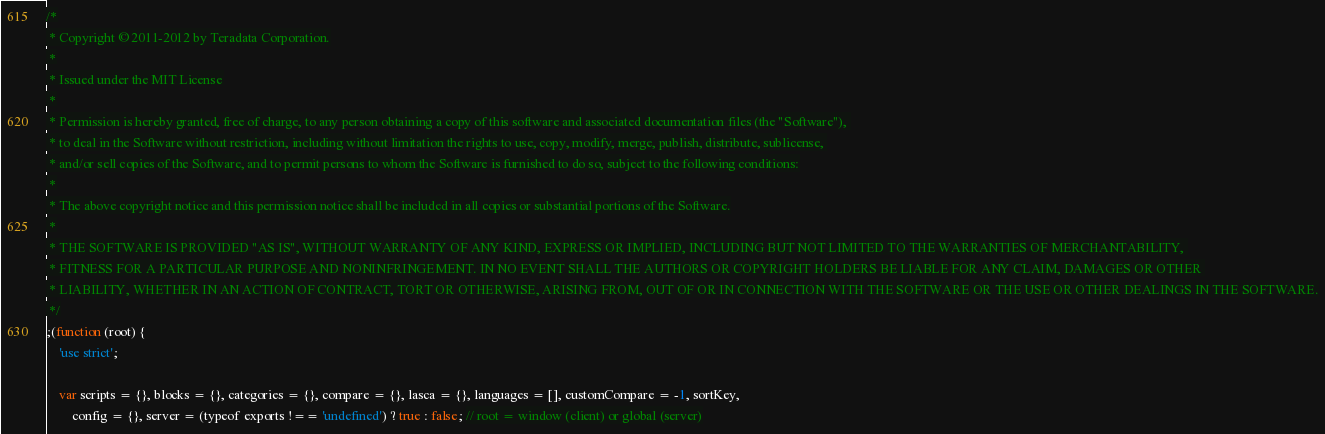<code> <loc_0><loc_0><loc_500><loc_500><_JavaScript_>/*
 * Copyright © 2011-2012 by Teradata Corporation.
 *
 * Issued under the MIT License
 *
 * Permission is hereby granted, free of charge, to any person obtaining a copy of this software and associated documentation files (the "Software"), 
 * to deal in the Software without restriction, including without limitation the rights to use, copy, modify, merge, publish, distribute, sublicense, 
 * and/or sell copies of the Software, and to permit persons to whom the Software is furnished to do so, subject to the following conditions:
 *
 * The above copyright notice and this permission notice shall be included in all copies or substantial portions of the Software.
 *
 * THE SOFTWARE IS PROVIDED "AS IS", WITHOUT WARRANTY OF ANY KIND, EXPRESS OR IMPLIED, INCLUDING BUT NOT LIMITED TO THE WARRANTIES OF MERCHANTABILITY, 
 * FITNESS FOR A PARTICULAR PURPOSE AND NONINFRINGEMENT. IN NO EVENT SHALL THE AUTHORS OR COPYRIGHT HOLDERS BE LIABLE FOR ANY CLAIM, DAMAGES OR OTHER 
 * LIABILITY, WHETHER IN AN ACTION OF CONTRACT, TORT OR OTHERWISE, ARISING FROM, OUT OF OR IN CONNECTION WITH THE SOFTWARE OR THE USE OR OTHER DEALINGS IN THE SOFTWARE.
 */
;(function (root) {
    'use strict';
    
    var scripts = {}, blocks = {}, categories = {}, compare = {}, lasca = {}, languages = [], customCompare = -1, sortKey,
        config = {}, server = (typeof exports !== 'undefined') ? true : false; // root = window (client) or global (server)
</code> 